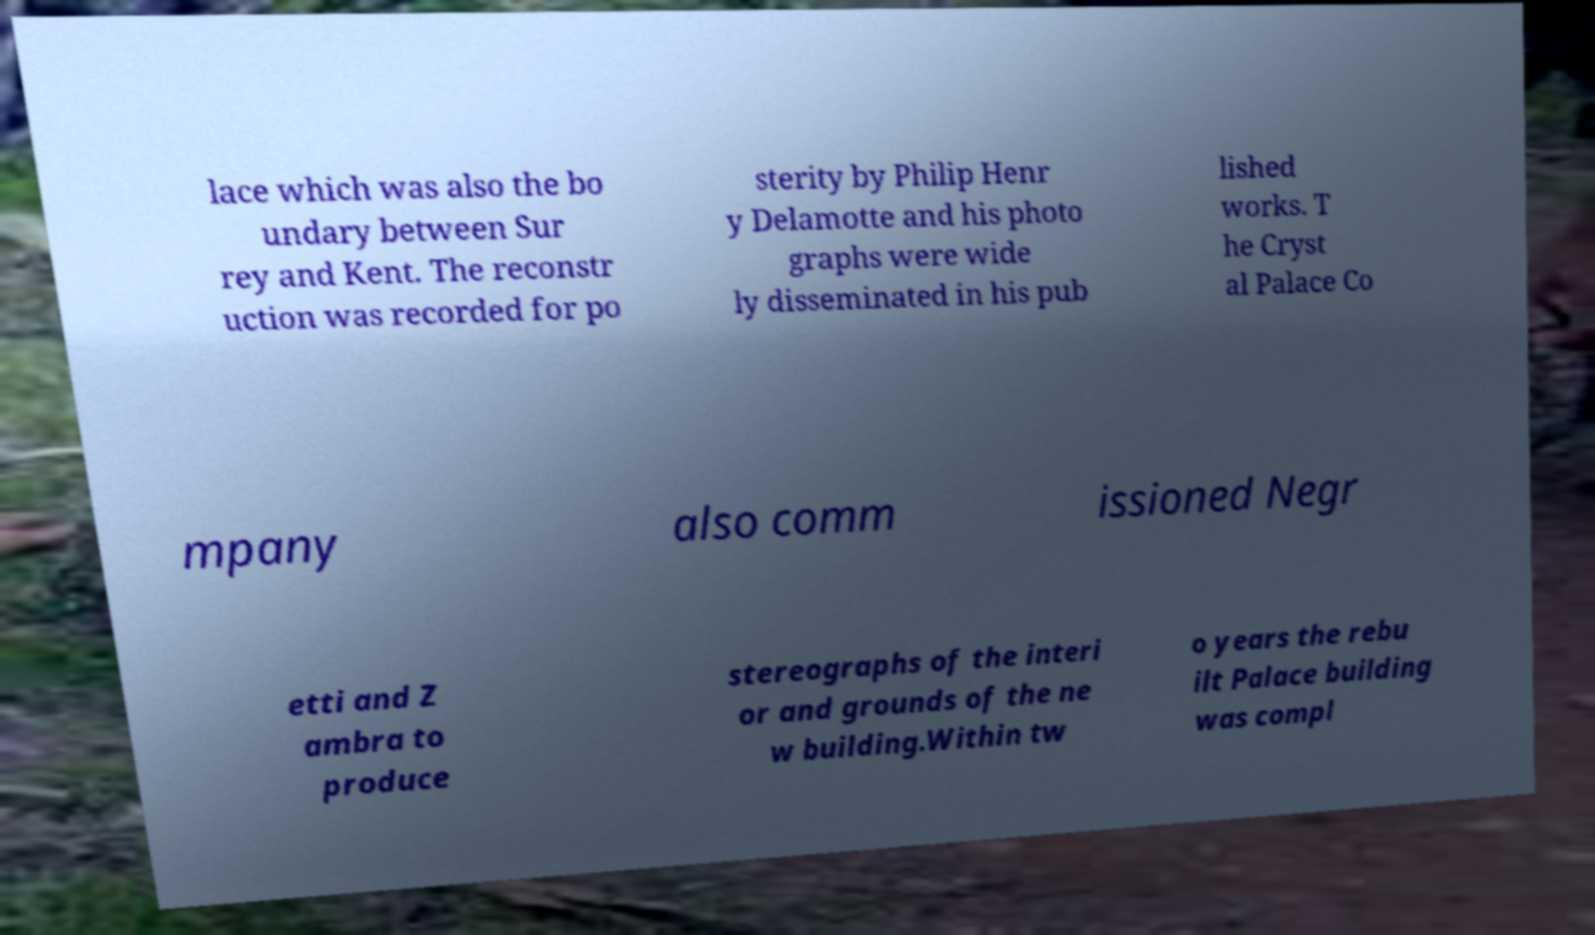Please identify and transcribe the text found in this image. lace which was also the bo undary between Sur rey and Kent. The reconstr uction was recorded for po sterity by Philip Henr y Delamotte and his photo graphs were wide ly disseminated in his pub lished works. T he Cryst al Palace Co mpany also comm issioned Negr etti and Z ambra to produce stereographs of the interi or and grounds of the ne w building.Within tw o years the rebu ilt Palace building was compl 